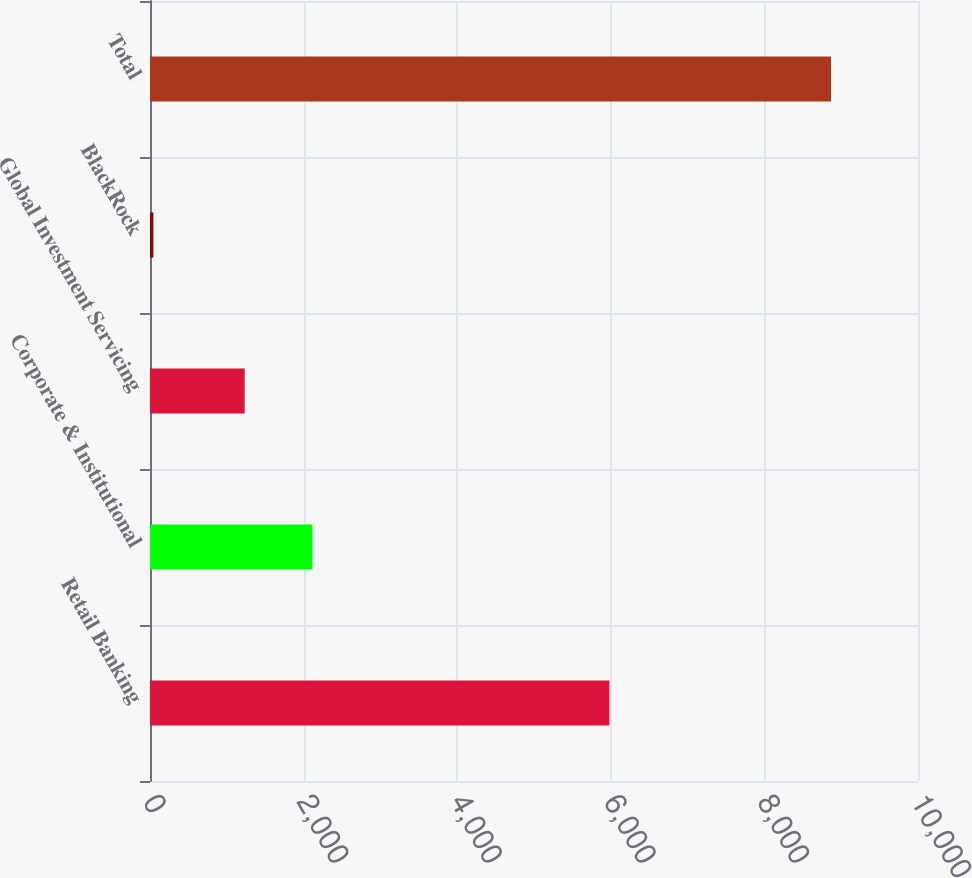<chart> <loc_0><loc_0><loc_500><loc_500><bar_chart><fcel>Retail Banking<fcel>Corporate & Institutional<fcel>Global Investment Servicing<fcel>BlackRock<fcel>Total<nl><fcel>5982<fcel>2115.4<fcel>1233<fcel>44<fcel>8868<nl></chart> 